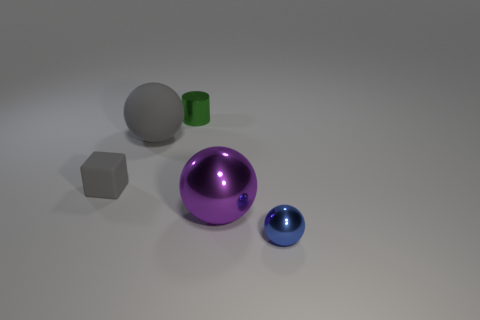Add 3 rubber cubes. How many objects exist? 8 Subtract all spheres. How many objects are left? 2 Subtract all gray blocks. Subtract all cyan balls. How many objects are left? 4 Add 3 small blue things. How many small blue things are left? 4 Add 5 small cyan matte balls. How many small cyan matte balls exist? 5 Subtract 0 red cylinders. How many objects are left? 5 